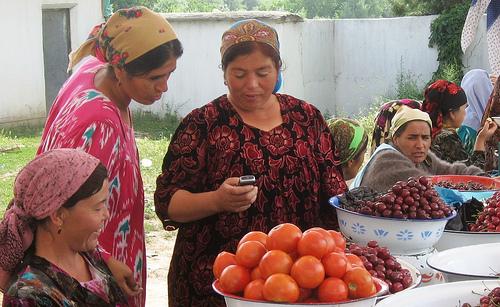What s in the white bowl?
Write a very short answer. Grapes. What pattern is on the outfit of the woman in the center?
Keep it brief. Flowers. What is on the women's heads?
Concise answer only. Scarves. 